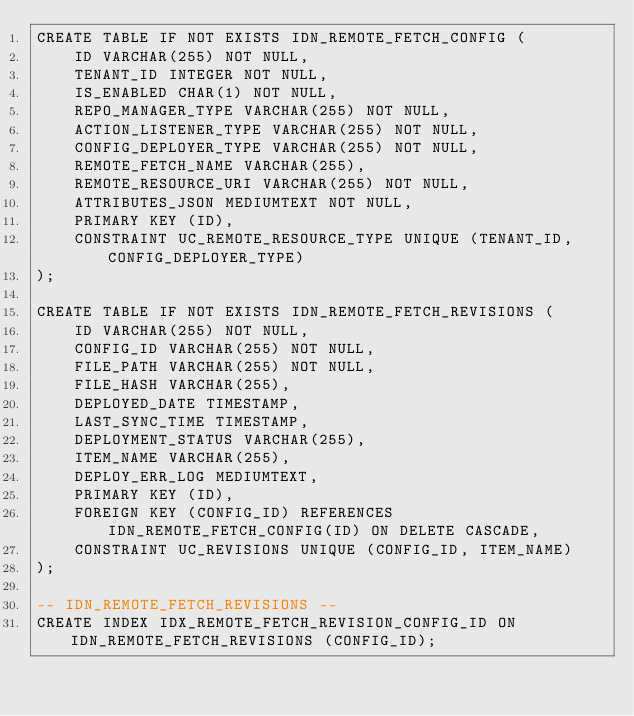Convert code to text. <code><loc_0><loc_0><loc_500><loc_500><_SQL_>CREATE TABLE IF NOT EXISTS IDN_REMOTE_FETCH_CONFIG (
	ID VARCHAR(255) NOT NULL,
	TENANT_ID INTEGER NOT NULL,
	IS_ENABLED CHAR(1) NOT NULL,
	REPO_MANAGER_TYPE VARCHAR(255) NOT NULL,
	ACTION_LISTENER_TYPE VARCHAR(255) NOT NULL,
	CONFIG_DEPLOYER_TYPE VARCHAR(255) NOT NULL,
	REMOTE_FETCH_NAME VARCHAR(255),
	REMOTE_RESOURCE_URI VARCHAR(255) NOT NULL,
	ATTRIBUTES_JSON MEDIUMTEXT NOT NULL,
	PRIMARY KEY (ID),
	CONSTRAINT UC_REMOTE_RESOURCE_TYPE UNIQUE (TENANT_ID, CONFIG_DEPLOYER_TYPE)
);

CREATE TABLE IF NOT EXISTS IDN_REMOTE_FETCH_REVISIONS (
	ID VARCHAR(255) NOT NULL,
	CONFIG_ID VARCHAR(255) NOT NULL,
	FILE_PATH VARCHAR(255) NOT NULL,
	FILE_HASH VARCHAR(255),
	DEPLOYED_DATE TIMESTAMP,
	LAST_SYNC_TIME TIMESTAMP,
	DEPLOYMENT_STATUS VARCHAR(255),
	ITEM_NAME VARCHAR(255),
	DEPLOY_ERR_LOG MEDIUMTEXT,
	PRIMARY KEY (ID),
	FOREIGN KEY (CONFIG_ID) REFERENCES IDN_REMOTE_FETCH_CONFIG(ID) ON DELETE CASCADE,
	CONSTRAINT UC_REVISIONS UNIQUE (CONFIG_ID, ITEM_NAME)
);

-- IDN_REMOTE_FETCH_REVISIONS --
CREATE INDEX IDX_REMOTE_FETCH_REVISION_CONFIG_ID ON IDN_REMOTE_FETCH_REVISIONS (CONFIG_ID);
</code> 